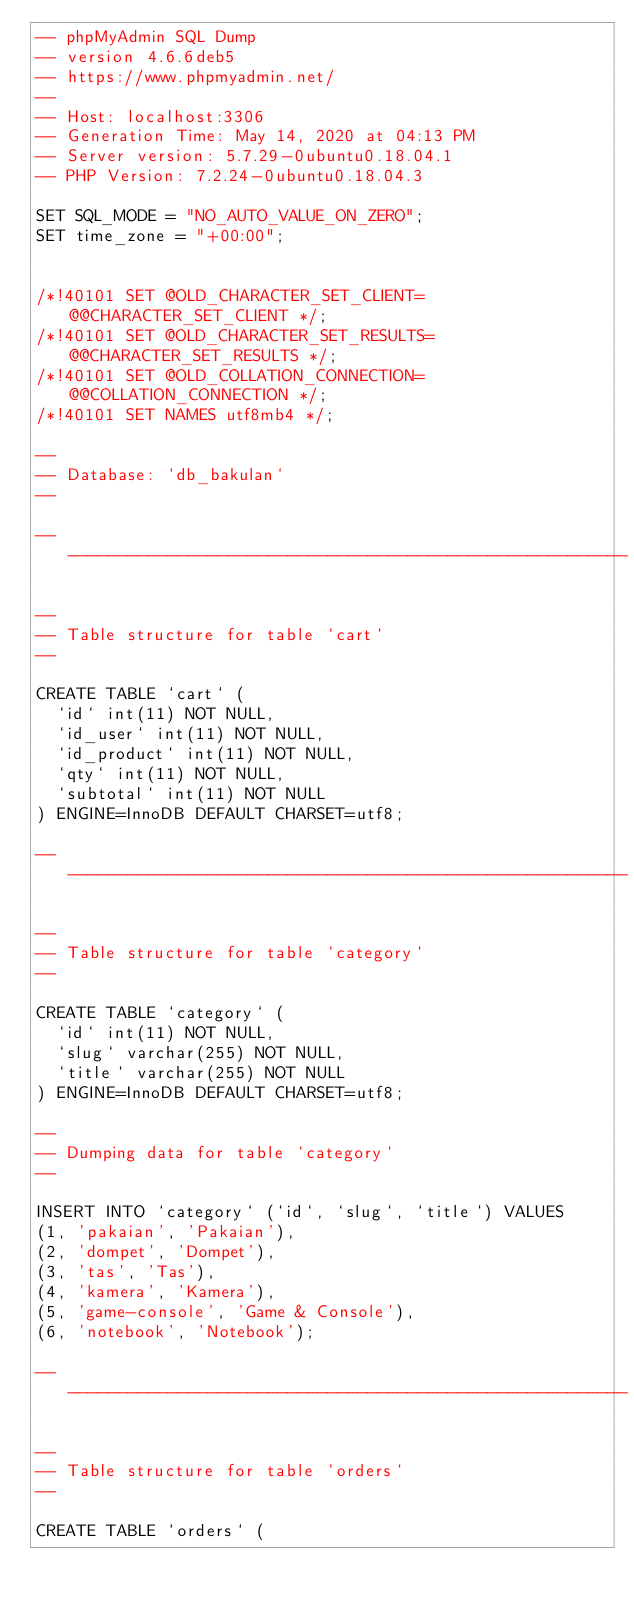Convert code to text. <code><loc_0><loc_0><loc_500><loc_500><_SQL_>-- phpMyAdmin SQL Dump
-- version 4.6.6deb5
-- https://www.phpmyadmin.net/
--
-- Host: localhost:3306
-- Generation Time: May 14, 2020 at 04:13 PM
-- Server version: 5.7.29-0ubuntu0.18.04.1
-- PHP Version: 7.2.24-0ubuntu0.18.04.3

SET SQL_MODE = "NO_AUTO_VALUE_ON_ZERO";
SET time_zone = "+00:00";


/*!40101 SET @OLD_CHARACTER_SET_CLIENT=@@CHARACTER_SET_CLIENT */;
/*!40101 SET @OLD_CHARACTER_SET_RESULTS=@@CHARACTER_SET_RESULTS */;
/*!40101 SET @OLD_COLLATION_CONNECTION=@@COLLATION_CONNECTION */;
/*!40101 SET NAMES utf8mb4 */;

--
-- Database: `db_bakulan`
--

-- --------------------------------------------------------

--
-- Table structure for table `cart`
--

CREATE TABLE `cart` (
  `id` int(11) NOT NULL,
  `id_user` int(11) NOT NULL,
  `id_product` int(11) NOT NULL,
  `qty` int(11) NOT NULL,
  `subtotal` int(11) NOT NULL
) ENGINE=InnoDB DEFAULT CHARSET=utf8;

-- --------------------------------------------------------

--
-- Table structure for table `category`
--

CREATE TABLE `category` (
  `id` int(11) NOT NULL,
  `slug` varchar(255) NOT NULL,
  `title` varchar(255) NOT NULL
) ENGINE=InnoDB DEFAULT CHARSET=utf8;

--
-- Dumping data for table `category`
--

INSERT INTO `category` (`id`, `slug`, `title`) VALUES
(1, 'pakaian', 'Pakaian'),
(2, 'dompet', 'Dompet'),
(3, 'tas', 'Tas'),
(4, 'kamera', 'Kamera'),
(5, 'game-console', 'Game & Console'),
(6, 'notebook', 'Notebook');

-- --------------------------------------------------------

--
-- Table structure for table `orders`
--

CREATE TABLE `orders` (</code> 